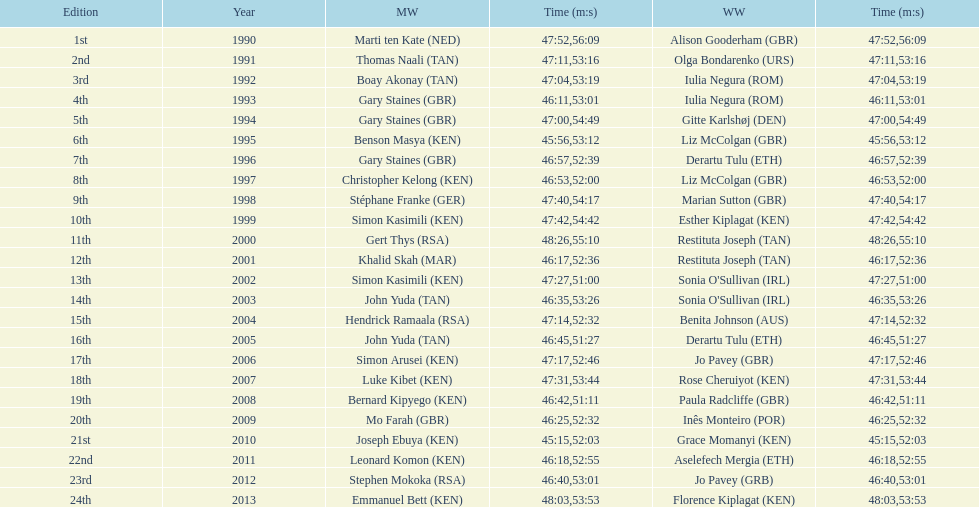How long did sonia o'sullivan take to finish in 2003? 53:26. 